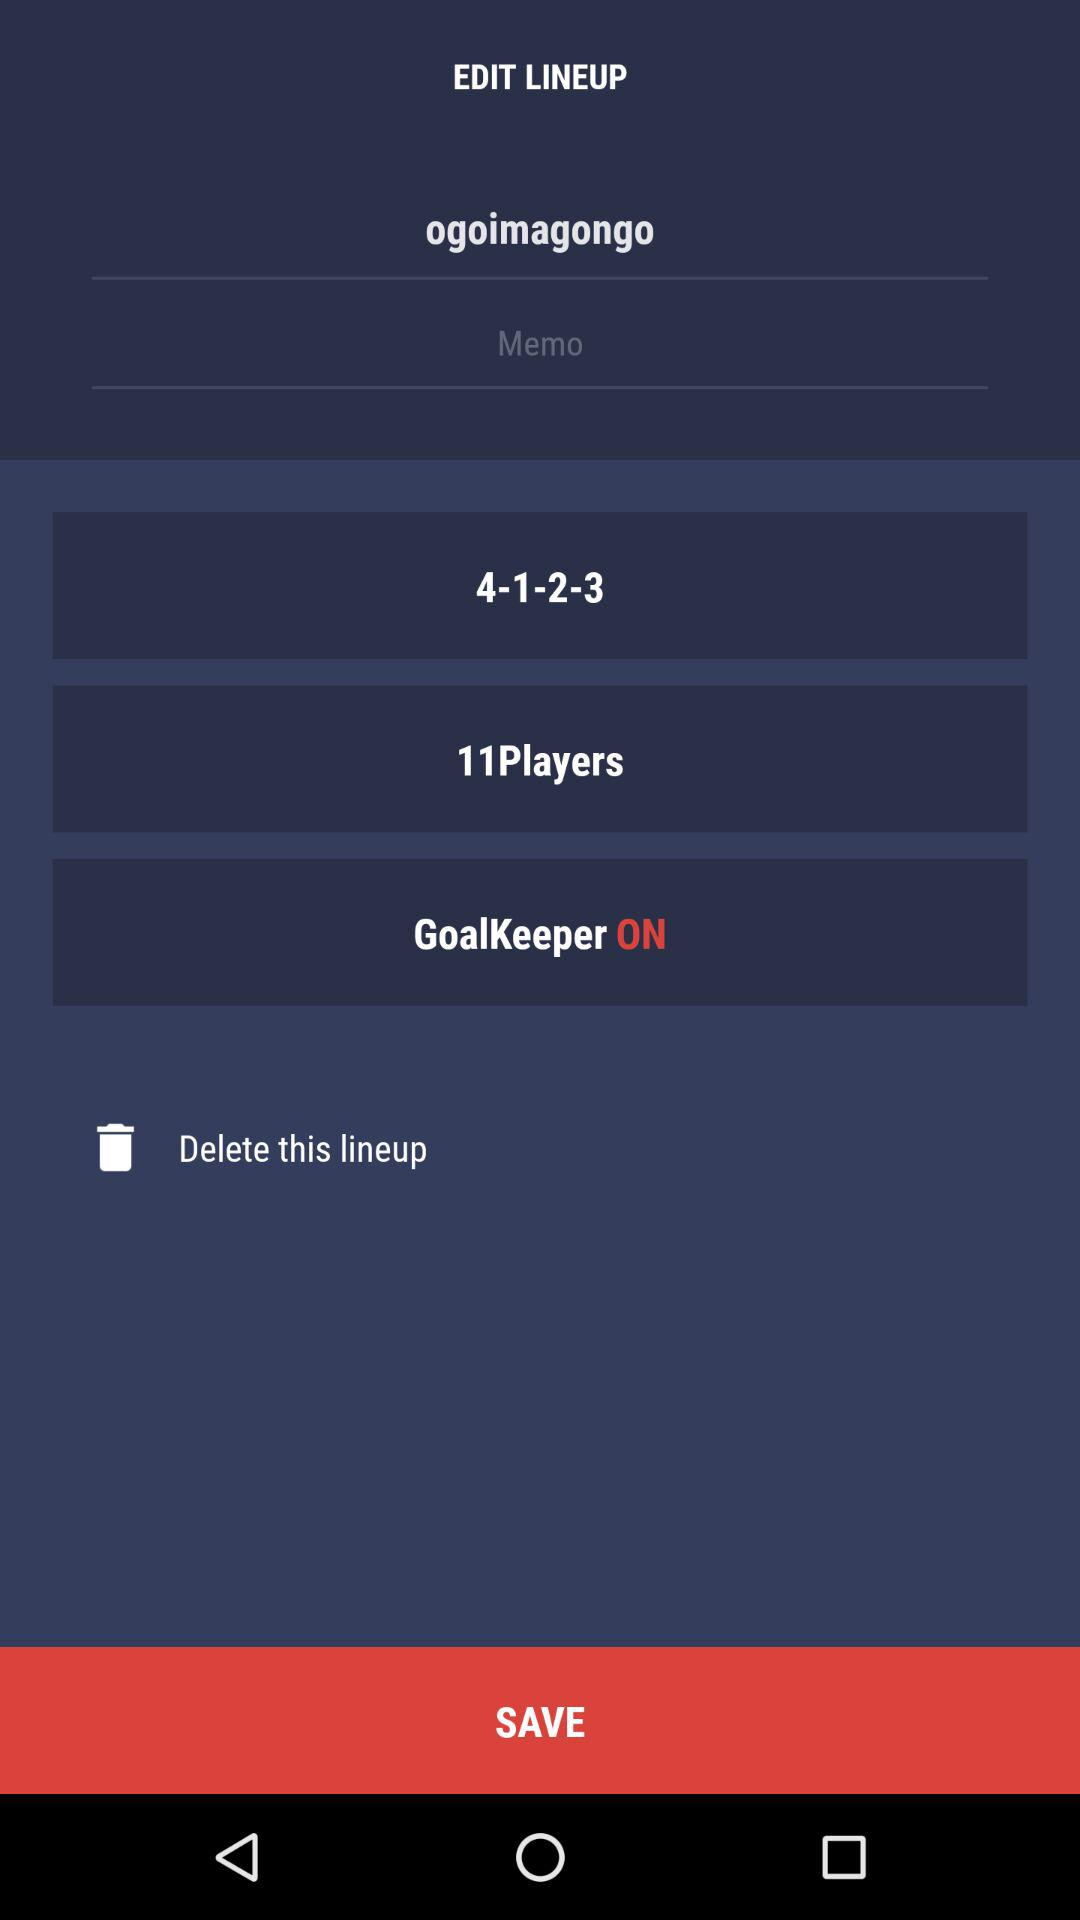What is the status of the goalkeeper? The status is on. 